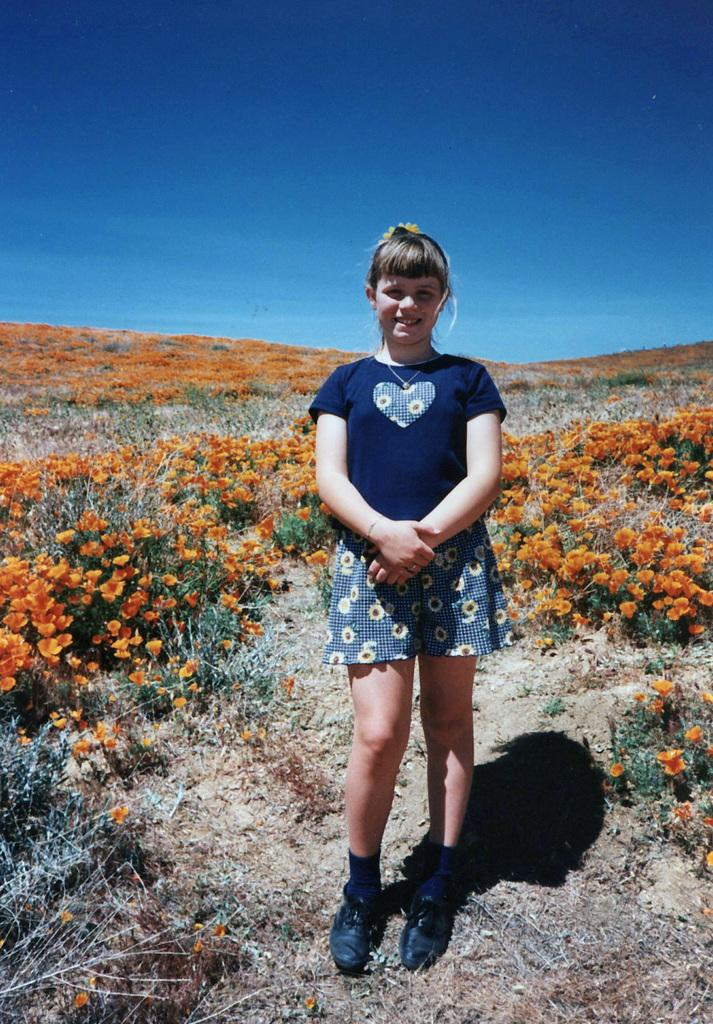What type of plants can be seen in the image? There are plants with orange color flowers in the image. What is the girl doing in the image? The girl is standing on the ground in the image. Where is the girl located in relation to the plants? The girl is in the middle of the plants. What can be seen in the background of the image? There is a sky visible in the background of the image. What type of fuel is the girl using to power her movements in the image? The girl is not using any fuel to power her movements in the image; she is simply standing on the ground. How many brothers does the girl have, and are they present in the image? There is no information about the girl's brothers in the image, and they are not mentioned in the provided facts. 